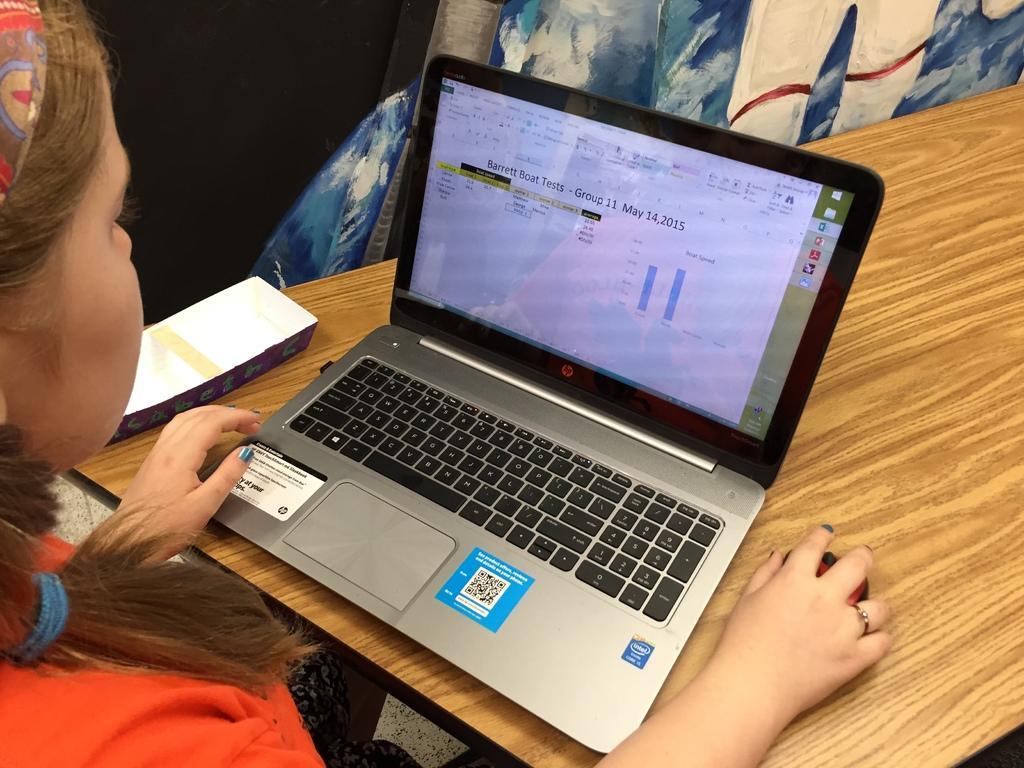Please provide a concise description of this image. In this image there is a lady sitting in front of the table, on which there is a laptop and other object. 